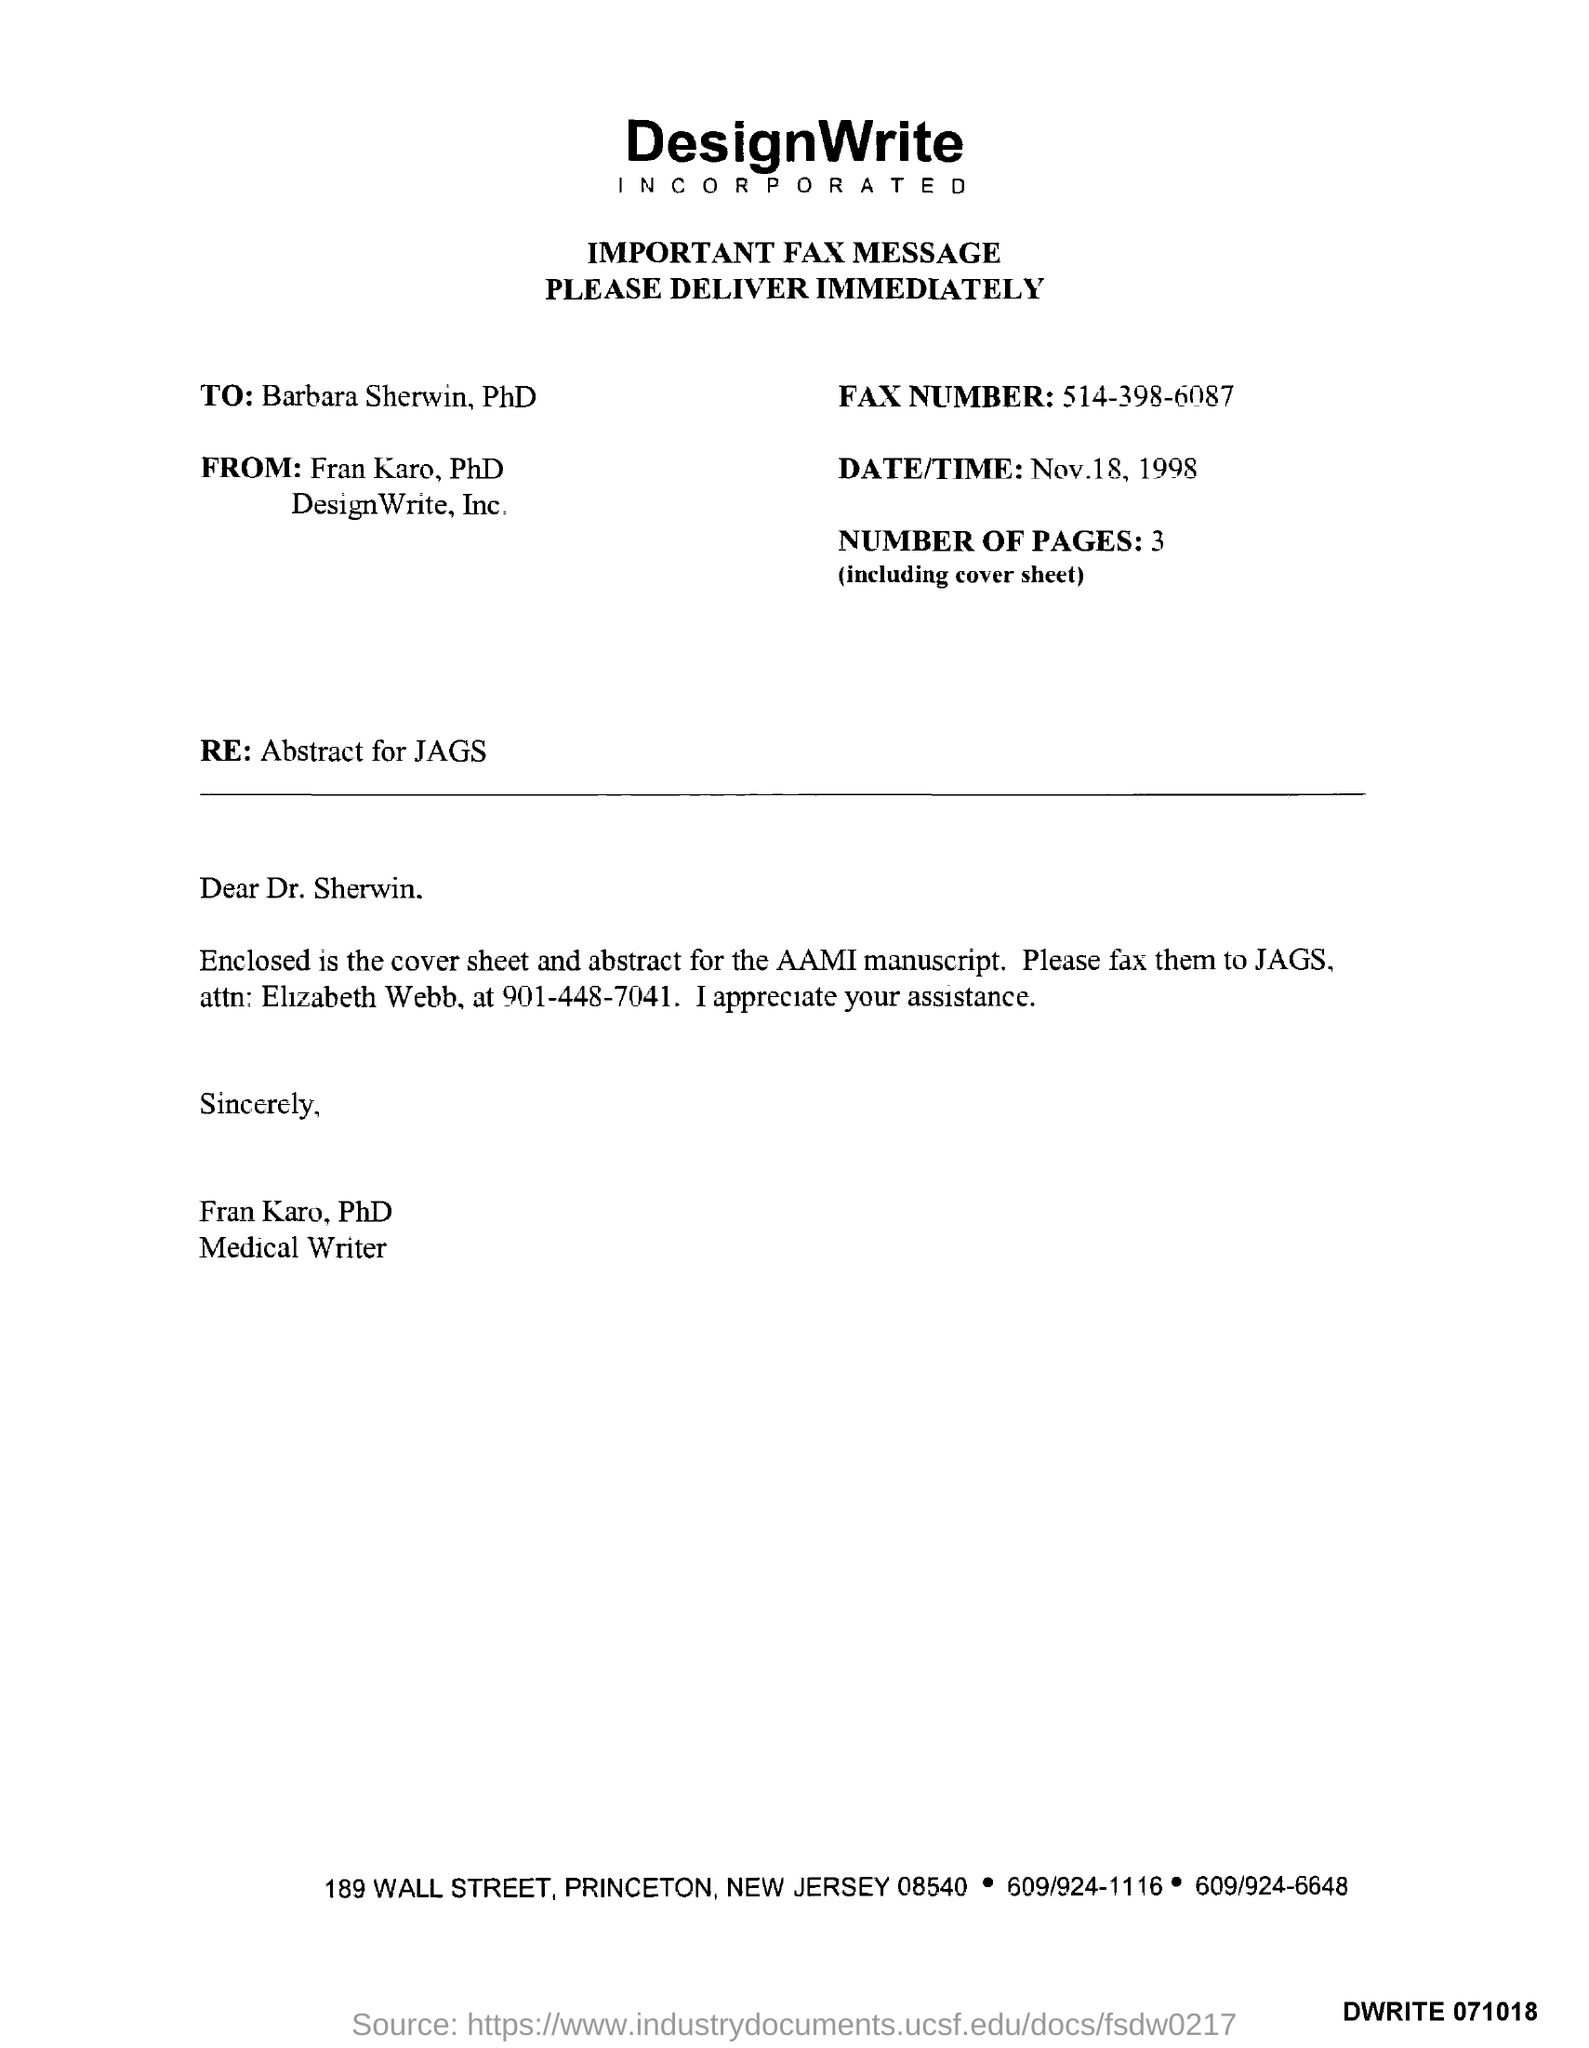What is written just below "Important Fax Message"?
Your answer should be compact. Please deliver immediately.. 